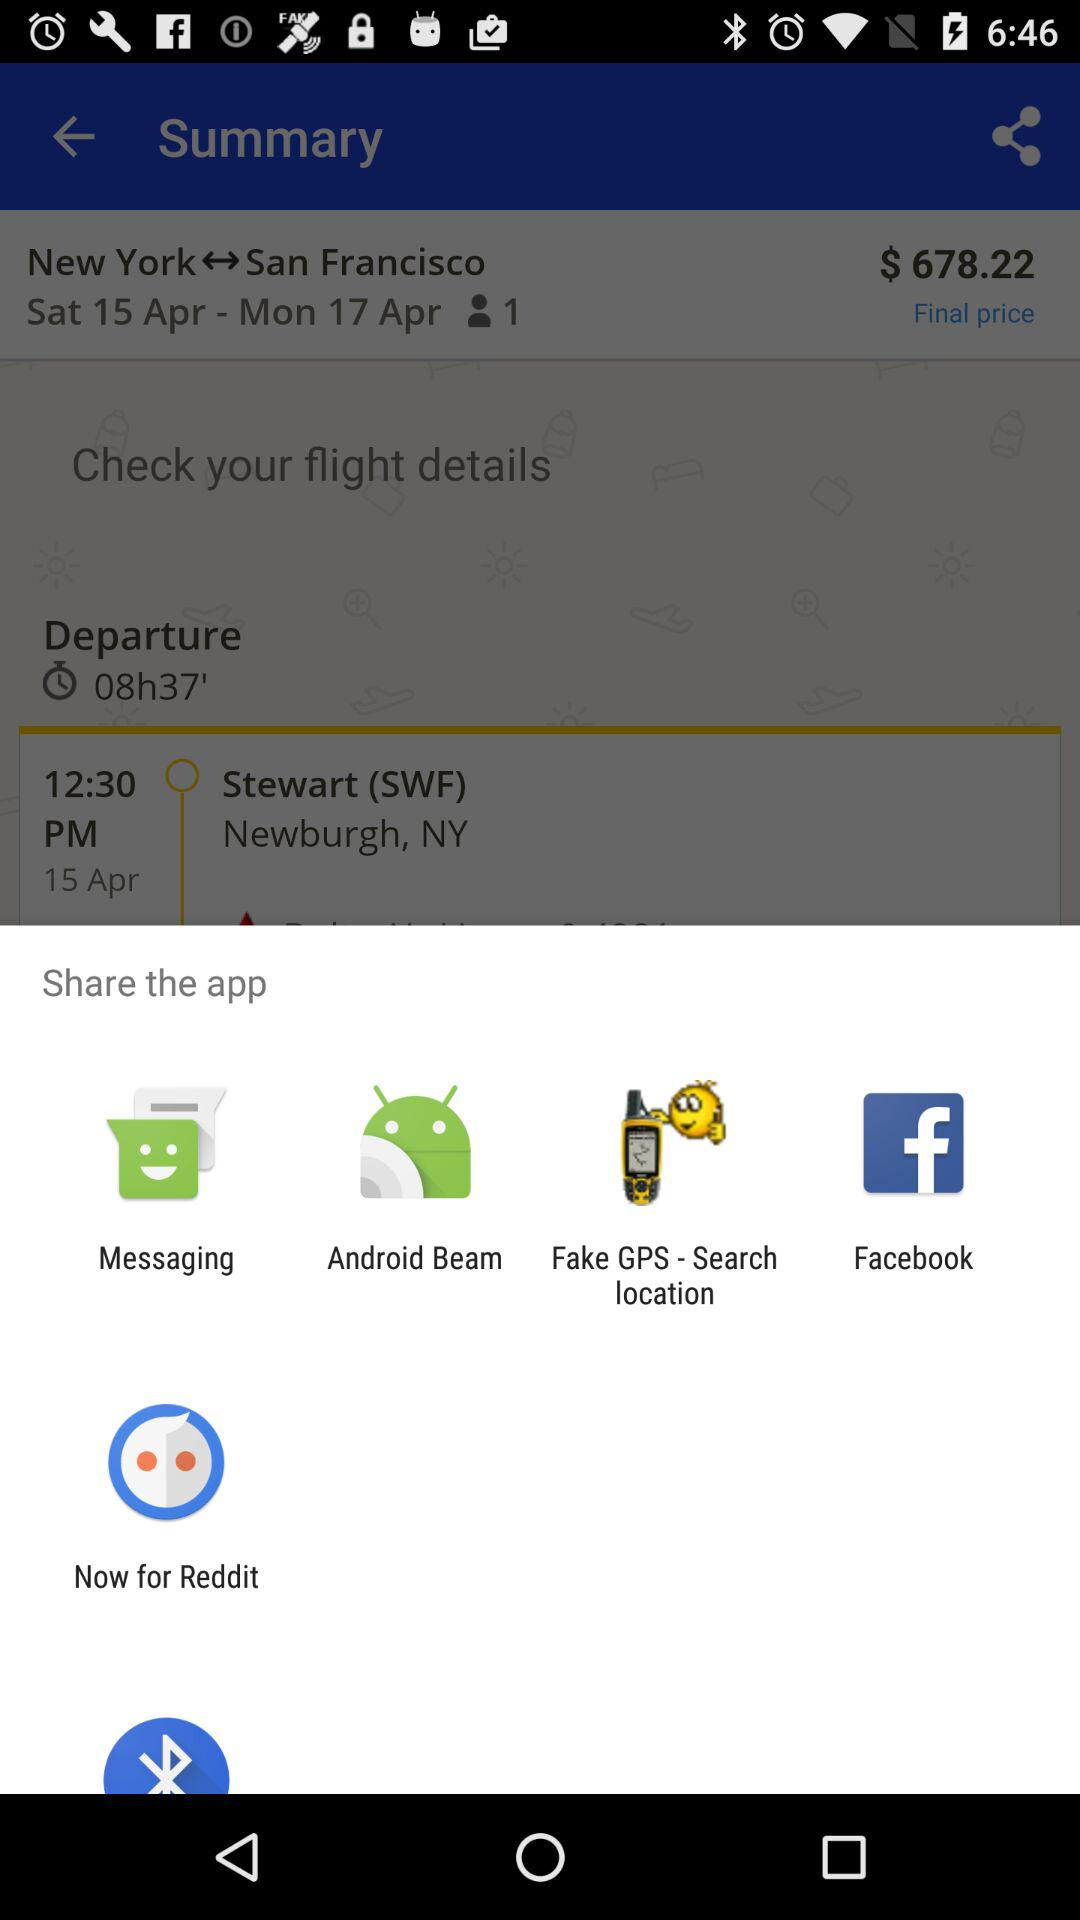How many more days are there between the departure and arrival dates?
Answer the question using a single word or phrase. 2 